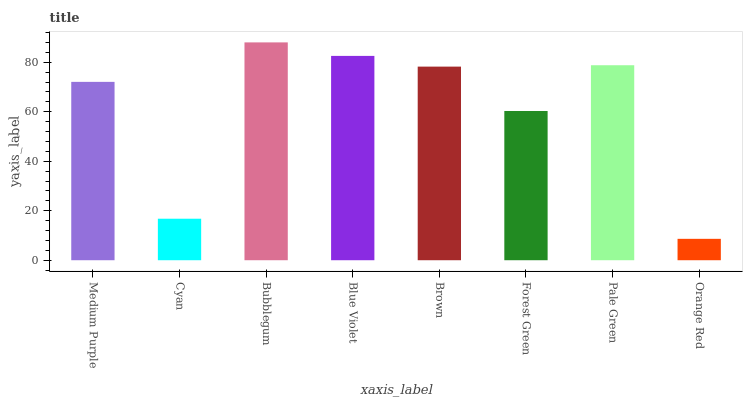Is Orange Red the minimum?
Answer yes or no. Yes. Is Bubblegum the maximum?
Answer yes or no. Yes. Is Cyan the minimum?
Answer yes or no. No. Is Cyan the maximum?
Answer yes or no. No. Is Medium Purple greater than Cyan?
Answer yes or no. Yes. Is Cyan less than Medium Purple?
Answer yes or no. Yes. Is Cyan greater than Medium Purple?
Answer yes or no. No. Is Medium Purple less than Cyan?
Answer yes or no. No. Is Brown the high median?
Answer yes or no. Yes. Is Medium Purple the low median?
Answer yes or no. Yes. Is Orange Red the high median?
Answer yes or no. No. Is Bubblegum the low median?
Answer yes or no. No. 